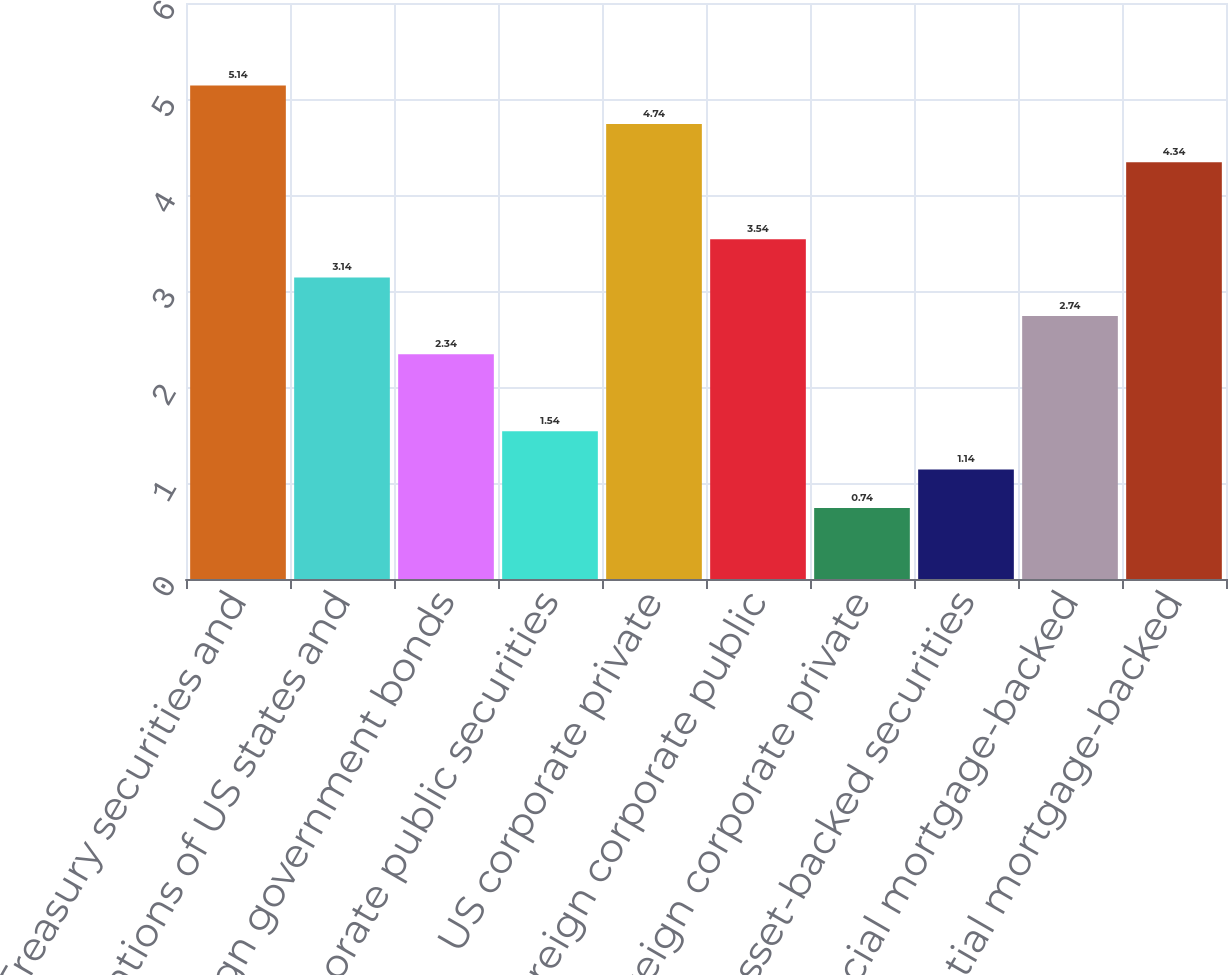<chart> <loc_0><loc_0><loc_500><loc_500><bar_chart><fcel>US Treasury securities and<fcel>Obligations of US states and<fcel>Foreign government bonds<fcel>US corporate public securities<fcel>US corporate private<fcel>Foreign corporate public<fcel>Foreign corporate private<fcel>Asset-backed securities<fcel>Commercial mortgage-backed<fcel>Residential mortgage-backed<nl><fcel>5.14<fcel>3.14<fcel>2.34<fcel>1.54<fcel>4.74<fcel>3.54<fcel>0.74<fcel>1.14<fcel>2.74<fcel>4.34<nl></chart> 